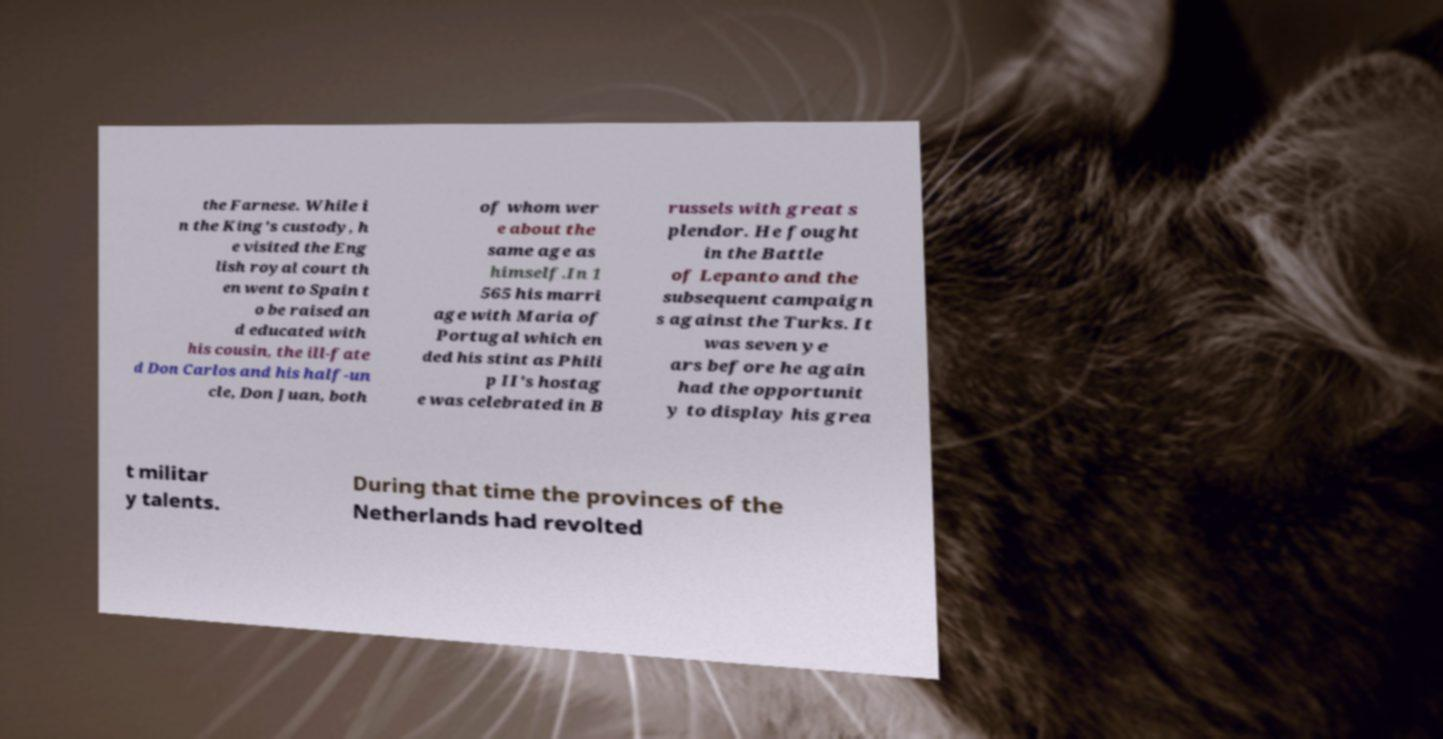Please read and relay the text visible in this image. What does it say? the Farnese. While i n the King's custody, h e visited the Eng lish royal court th en went to Spain t o be raised an d educated with his cousin, the ill-fate d Don Carlos and his half-un cle, Don Juan, both of whom wer e about the same age as himself.In 1 565 his marri age with Maria of Portugal which en ded his stint as Phili p II's hostag e was celebrated in B russels with great s plendor. He fought in the Battle of Lepanto and the subsequent campaign s against the Turks. It was seven ye ars before he again had the opportunit y to display his grea t militar y talents. During that time the provinces of the Netherlands had revolted 